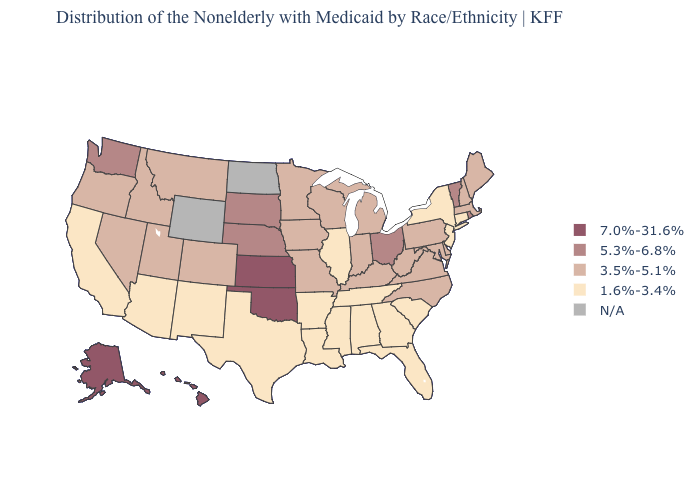How many symbols are there in the legend?
Short answer required. 5. What is the value of Alabama?
Be succinct. 1.6%-3.4%. What is the value of Louisiana?
Answer briefly. 1.6%-3.4%. Does Missouri have the lowest value in the MidWest?
Be succinct. No. Name the states that have a value in the range 1.6%-3.4%?
Write a very short answer. Alabama, Arizona, Arkansas, California, Connecticut, Florida, Georgia, Illinois, Louisiana, Mississippi, New Jersey, New Mexico, New York, South Carolina, Tennessee, Texas. Does Nevada have the lowest value in the West?
Concise answer only. No. Name the states that have a value in the range 5.3%-6.8%?
Quick response, please. Nebraska, Ohio, Rhode Island, South Dakota, Vermont, Washington. Name the states that have a value in the range 7.0%-31.6%?
Keep it brief. Alaska, Hawaii, Kansas, Oklahoma. Does Arkansas have the lowest value in the South?
Concise answer only. Yes. Does the map have missing data?
Concise answer only. Yes. What is the value of South Dakota?
Short answer required. 5.3%-6.8%. Does the map have missing data?
Write a very short answer. Yes. What is the highest value in states that border Pennsylvania?
Concise answer only. 5.3%-6.8%. What is the lowest value in states that border Kentucky?
Write a very short answer. 1.6%-3.4%. 